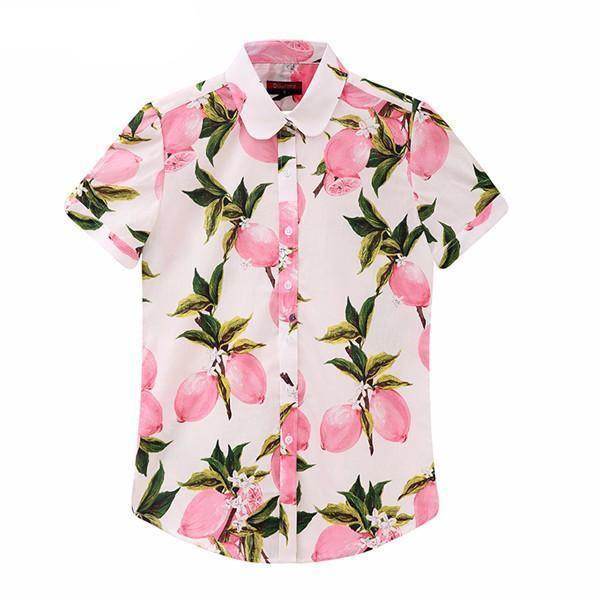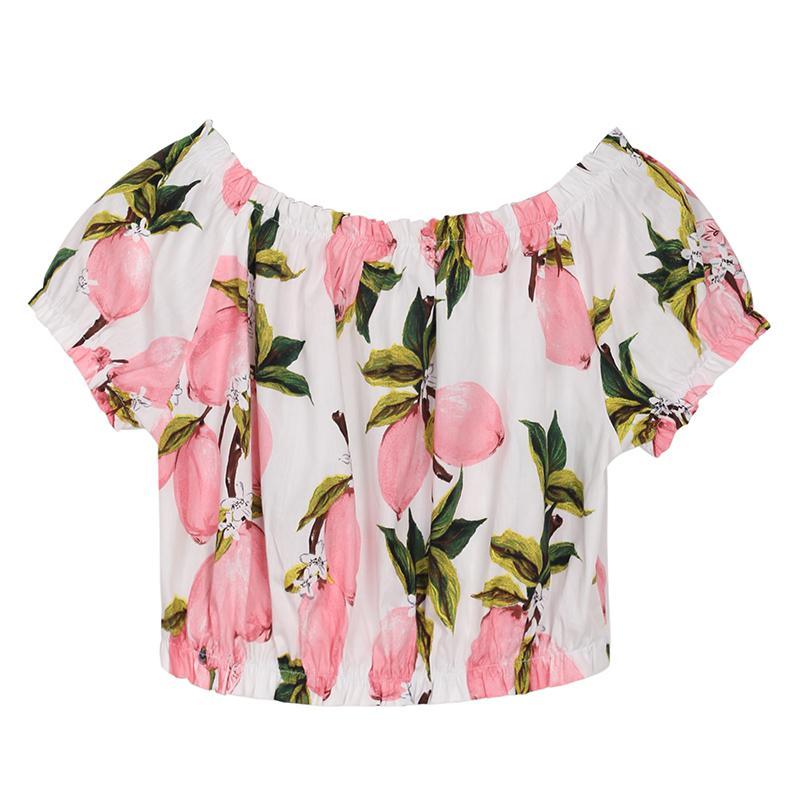The first image is the image on the left, the second image is the image on the right. Examine the images to the left and right. Is the description "One shirt is on a hanger." accurate? Answer yes or no. No. The first image is the image on the left, the second image is the image on the right. For the images shown, is this caption "Each image contains a top with a printed pattern that includes pink fruits." true? Answer yes or no. Yes. 